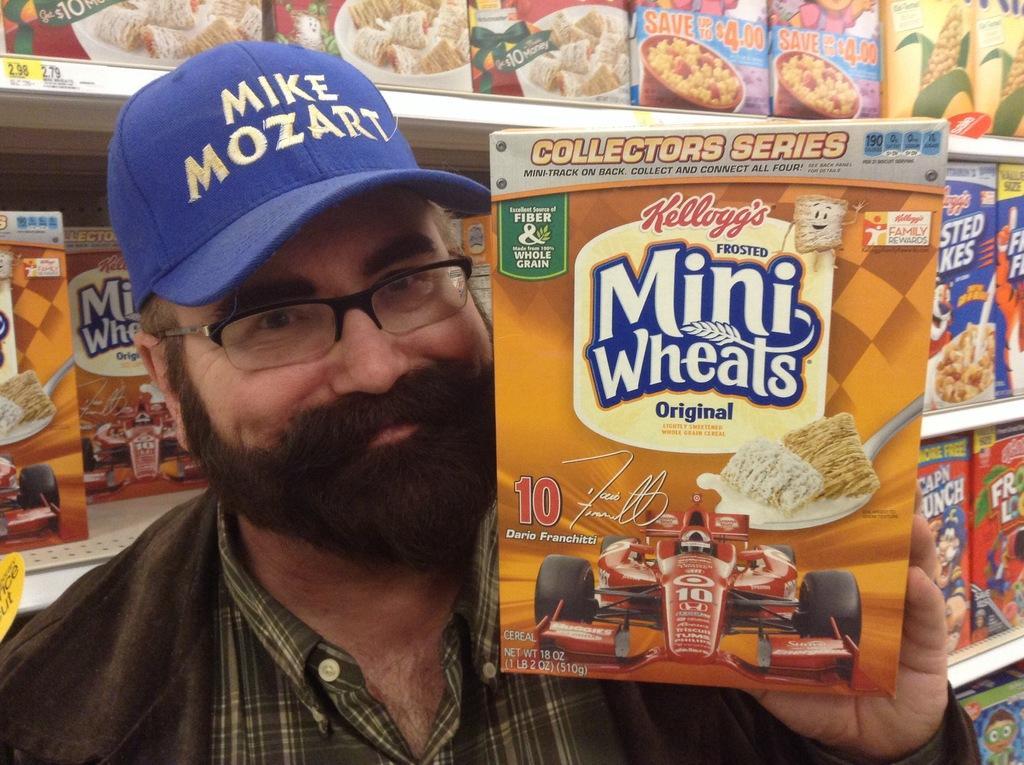In one or two sentences, can you explain what this image depicts? In this picture we can see a man wore a cap, spectacles, holding a box with his hand and smiling. In the background we can see boxes on shelves. 